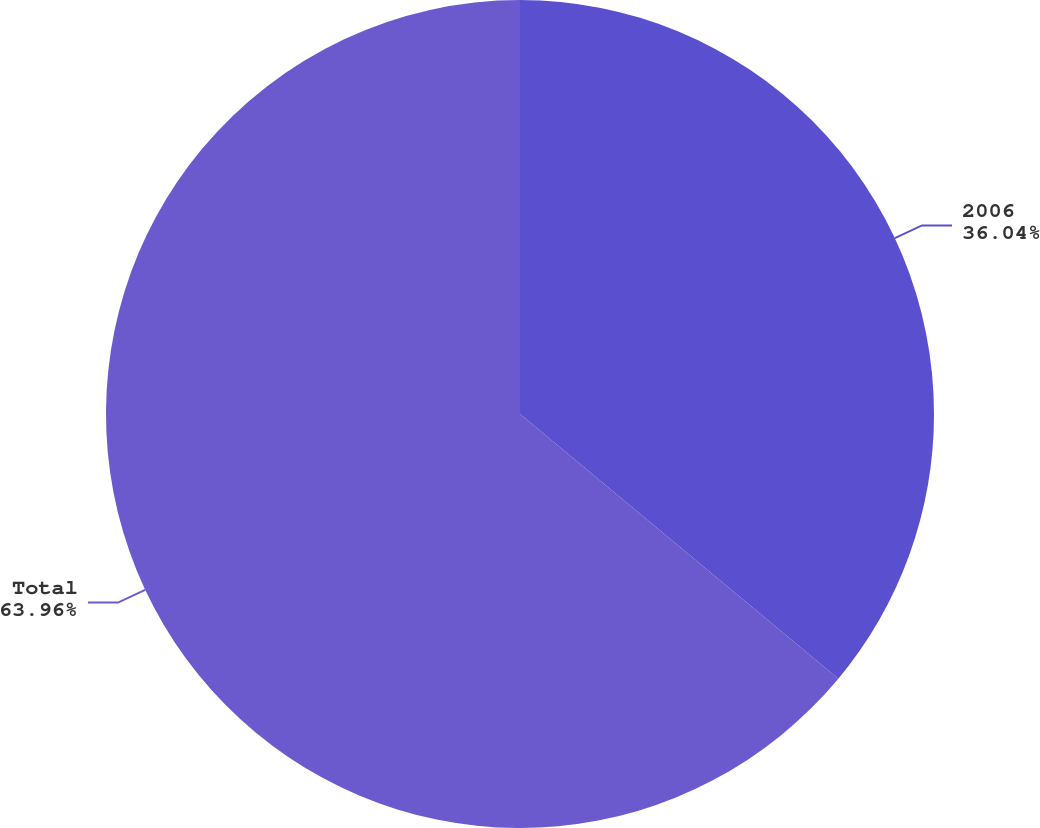Convert chart. <chart><loc_0><loc_0><loc_500><loc_500><pie_chart><fcel>2006<fcel>Total<nl><fcel>36.04%<fcel>63.96%<nl></chart> 